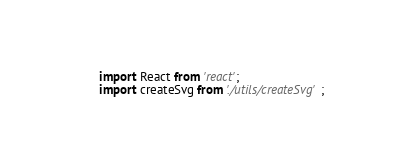<code> <loc_0><loc_0><loc_500><loc_500><_JavaScript_>import React from 'react';
import createSvg from './utils/createSvg';
</code> 